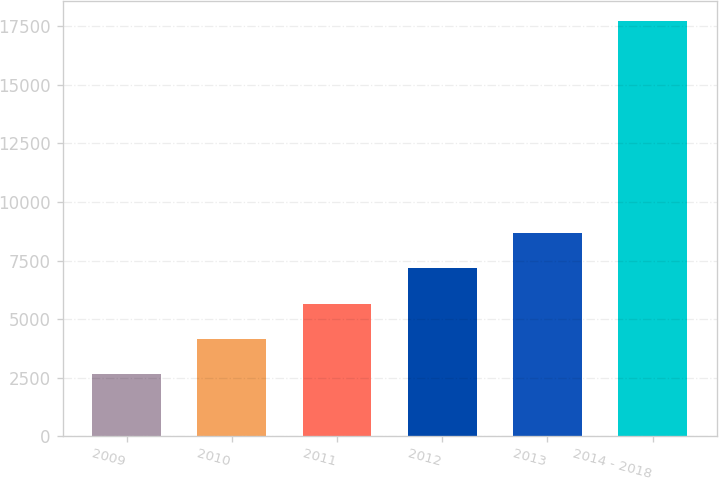Convert chart. <chart><loc_0><loc_0><loc_500><loc_500><bar_chart><fcel>2009<fcel>2010<fcel>2011<fcel>2012<fcel>2013<fcel>2014 - 2018<nl><fcel>2643<fcel>4149.5<fcel>5656<fcel>7162.5<fcel>8669<fcel>17708<nl></chart> 